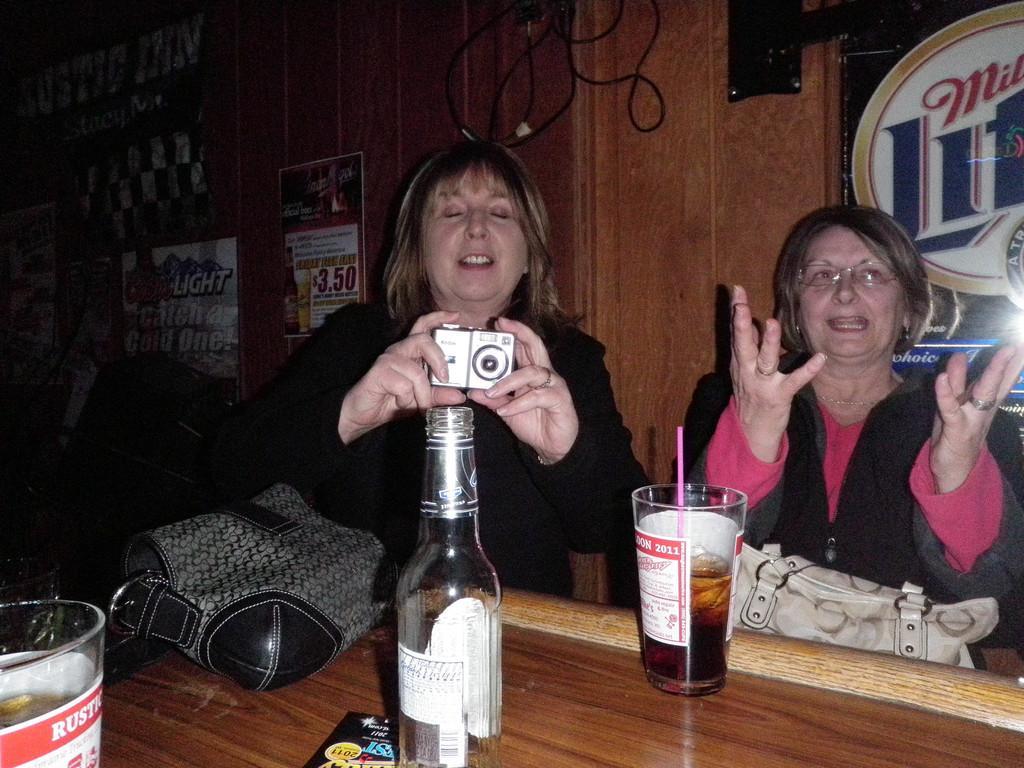How would you summarize this image in a sentence or two? In the image there are two woman sat and in front of them there is a table with a wine bottle and a glass and lady in the middle holding a camera. 